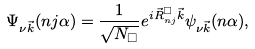<formula> <loc_0><loc_0><loc_500><loc_500>\Psi _ { \nu \vec { k } } ( n j \alpha ) = \frac { 1 } { \sqrt { N _ { \Box } } } e ^ { i \vec { R } _ { n j } ^ { \Box } \vec { k } } \psi _ { \nu \vec { k } } ( n \alpha ) ,</formula> 